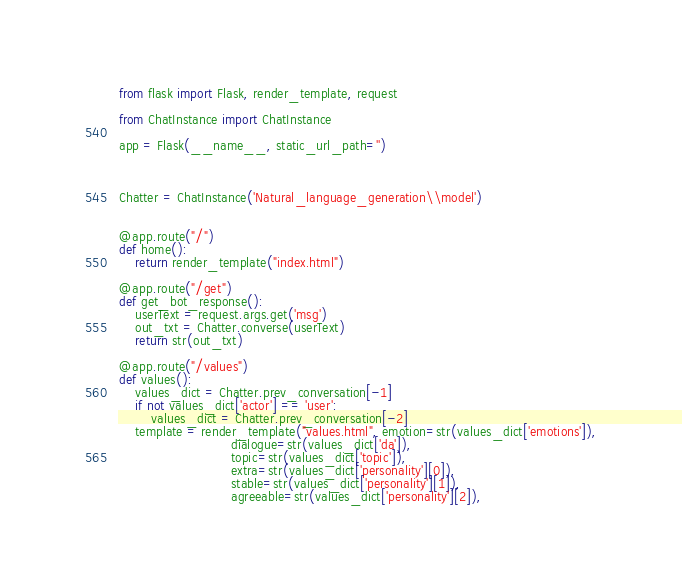<code> <loc_0><loc_0><loc_500><loc_500><_Python_>from flask import Flask, render_template, request

from ChatInstance import ChatInstance

app = Flask(__name__, static_url_path='')



Chatter = ChatInstance('Natural_language_generation\\model')


@app.route("/")
def home():
    return render_template("index.html")
    
@app.route("/get")
def get_bot_response():
    userText = request.args.get('msg')
    out_txt = Chatter.converse(userText)
    return str(out_txt)
    
@app.route("/values")
def values():
    values_dict = Chatter.prev_conversation[-1]
    if not values_dict['actor'] == 'user':
        values_dict = Chatter.prev_conversation[-2]
    template = render_template("values.html", emotion=str(values_dict['emotions']),
                            dialogue=str(values_dict['da']),
                            topic=str(values_dict['topic']),
                            extra=str(values_dict['personality'][0]),
                            stable=str(values_dict['personality'][1]),
                            agreeable=str(values_dict['personality'][2]),</code> 